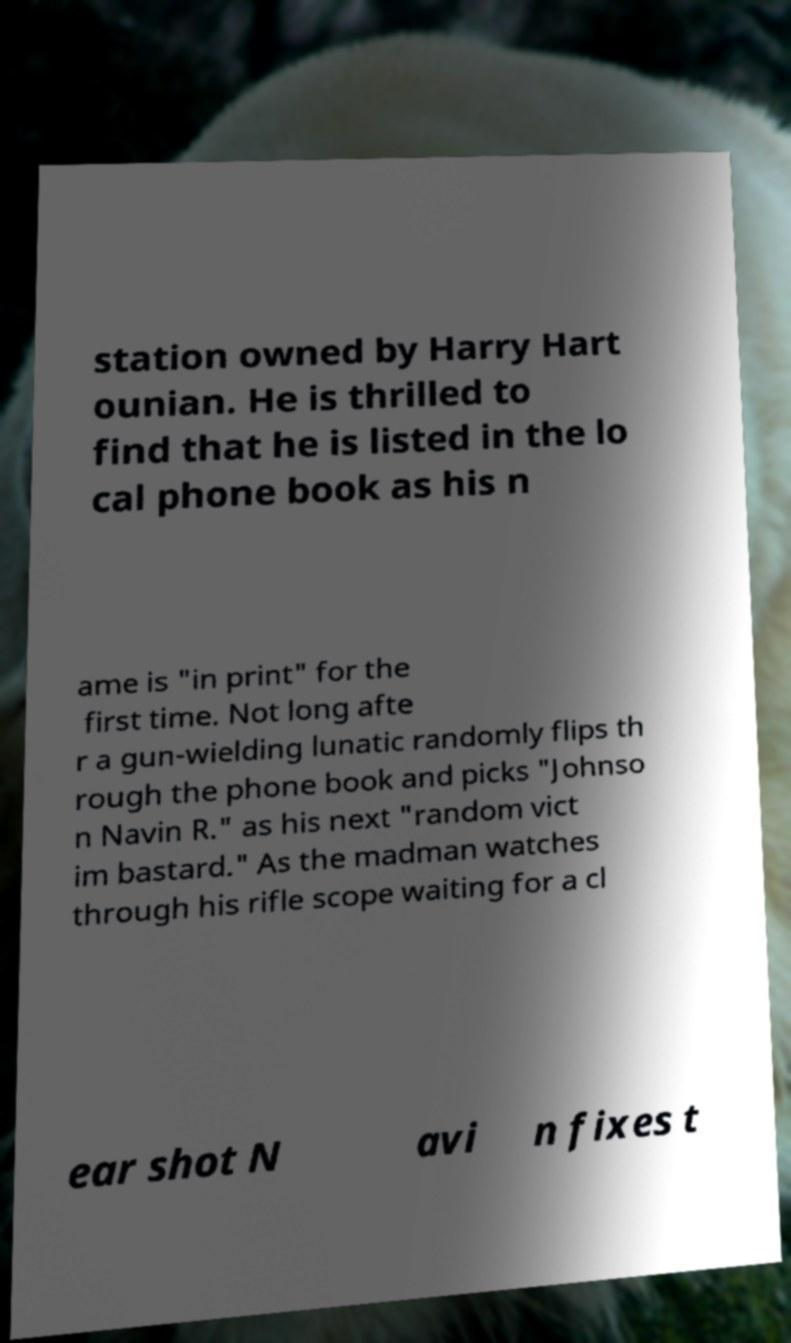Can you accurately transcribe the text from the provided image for me? station owned by Harry Hart ounian. He is thrilled to find that he is listed in the lo cal phone book as his n ame is "in print" for the first time. Not long afte r a gun-wielding lunatic randomly flips th rough the phone book and picks "Johnso n Navin R." as his next "random vict im bastard." As the madman watches through his rifle scope waiting for a cl ear shot N avi n fixes t 